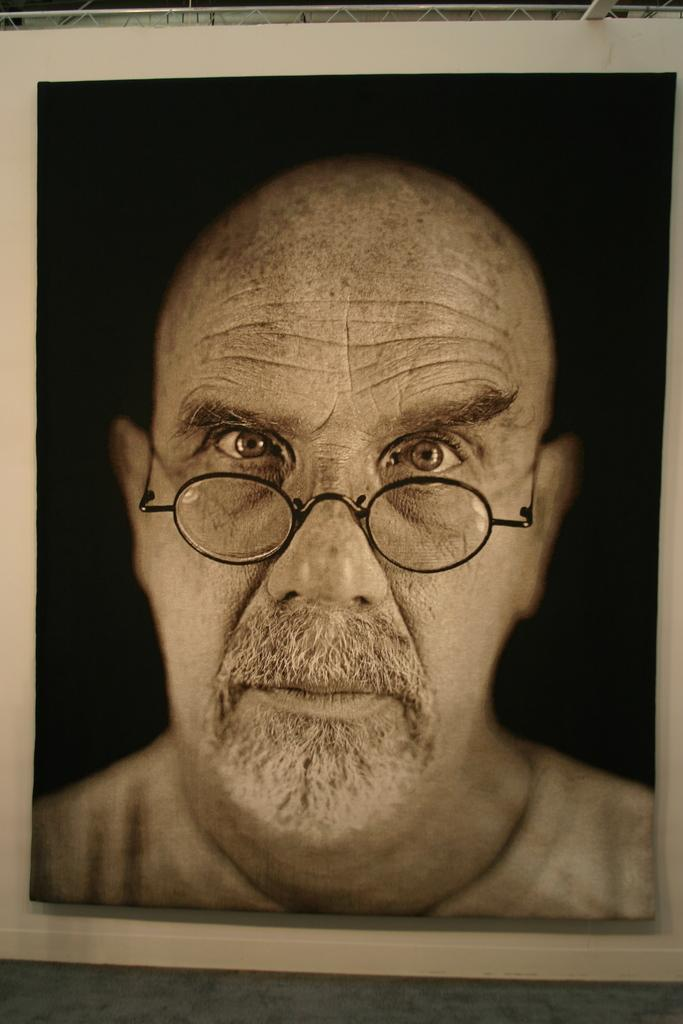What object in the image contains a picture? There is a photo frame in the image that contains a picture. What is depicted in the picture inside the photo frame? The picture inside the photo frame is of a person. What accessory is the person in the photo frame wearing? The person in the photo frame is wearing spectacles. What type of zephyr can be seen in the image? There is no zephyr present in the image. How many grapes are visible in the image? There are no grapes present in the image. What type of balls are being used in the image? There are no balls present in the image. 